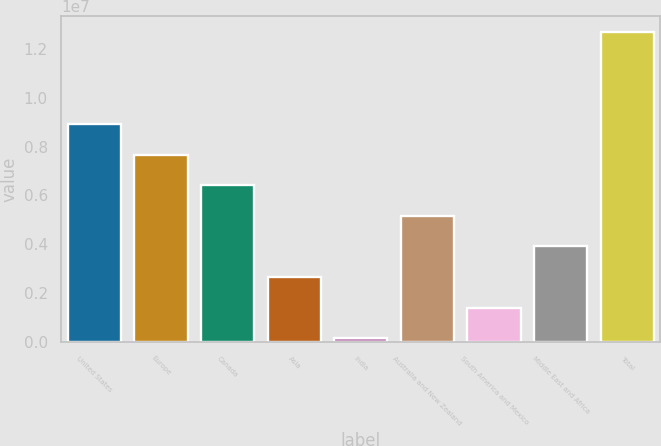Convert chart to OTSL. <chart><loc_0><loc_0><loc_500><loc_500><bar_chart><fcel>United States<fcel>Europe<fcel>Canada<fcel>Asia<fcel>India<fcel>Australia and New Zealand<fcel>South America and Mexico<fcel>Middle East and Africa<fcel>Total<nl><fcel>8.93115e+06<fcel>7.67648e+06<fcel>6.4218e+06<fcel>2.65779e+06<fcel>148453<fcel>5.16713e+06<fcel>1.40312e+06<fcel>3.91246e+06<fcel>1.26952e+07<nl></chart> 